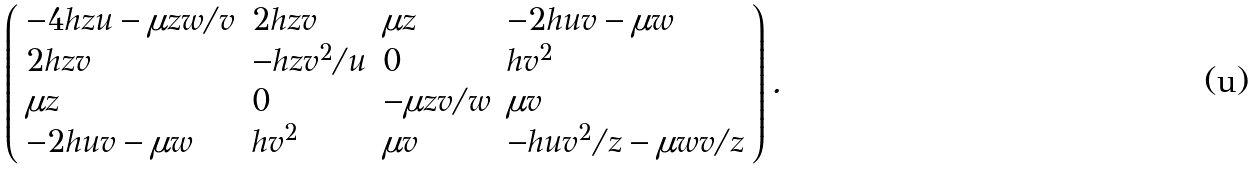<formula> <loc_0><loc_0><loc_500><loc_500>\left ( \begin{array} { l l l l } { - 4 h z u - \mu z w / v } & { 2 h z v } & { \mu z } & { - 2 h u v - \mu w } \\ { 2 h z v } & { { - h z v ^ { 2 } / u } } & { 0 } & { { h v ^ { 2 } } } \\ { \mu z } & { 0 } & { - \mu z v / w } & { \mu v } \\ { - 2 h u v - \mu w } & { { h v ^ { 2 } } } & { \mu v } & { { - h u v ^ { 2 } / z - \mu w v / z } } \end{array} \right ) .</formula> 